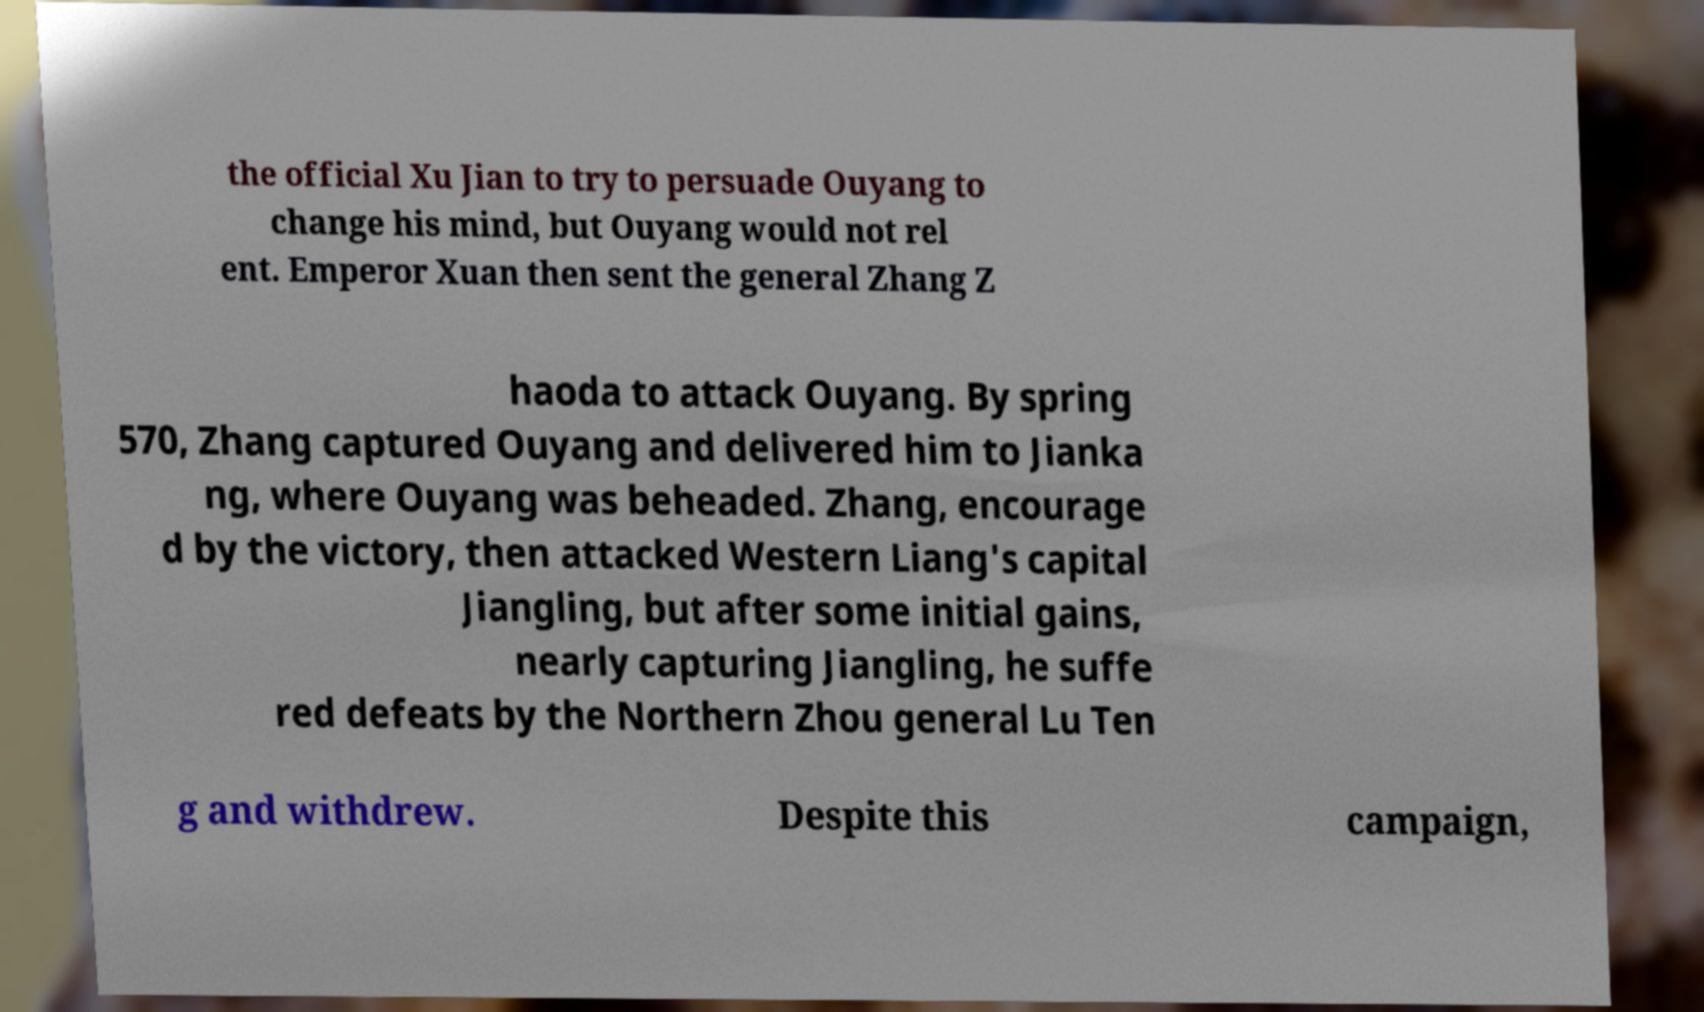Can you accurately transcribe the text from the provided image for me? the official Xu Jian to try to persuade Ouyang to change his mind, but Ouyang would not rel ent. Emperor Xuan then sent the general Zhang Z haoda to attack Ouyang. By spring 570, Zhang captured Ouyang and delivered him to Jianka ng, where Ouyang was beheaded. Zhang, encourage d by the victory, then attacked Western Liang's capital Jiangling, but after some initial gains, nearly capturing Jiangling, he suffe red defeats by the Northern Zhou general Lu Ten g and withdrew. Despite this campaign, 